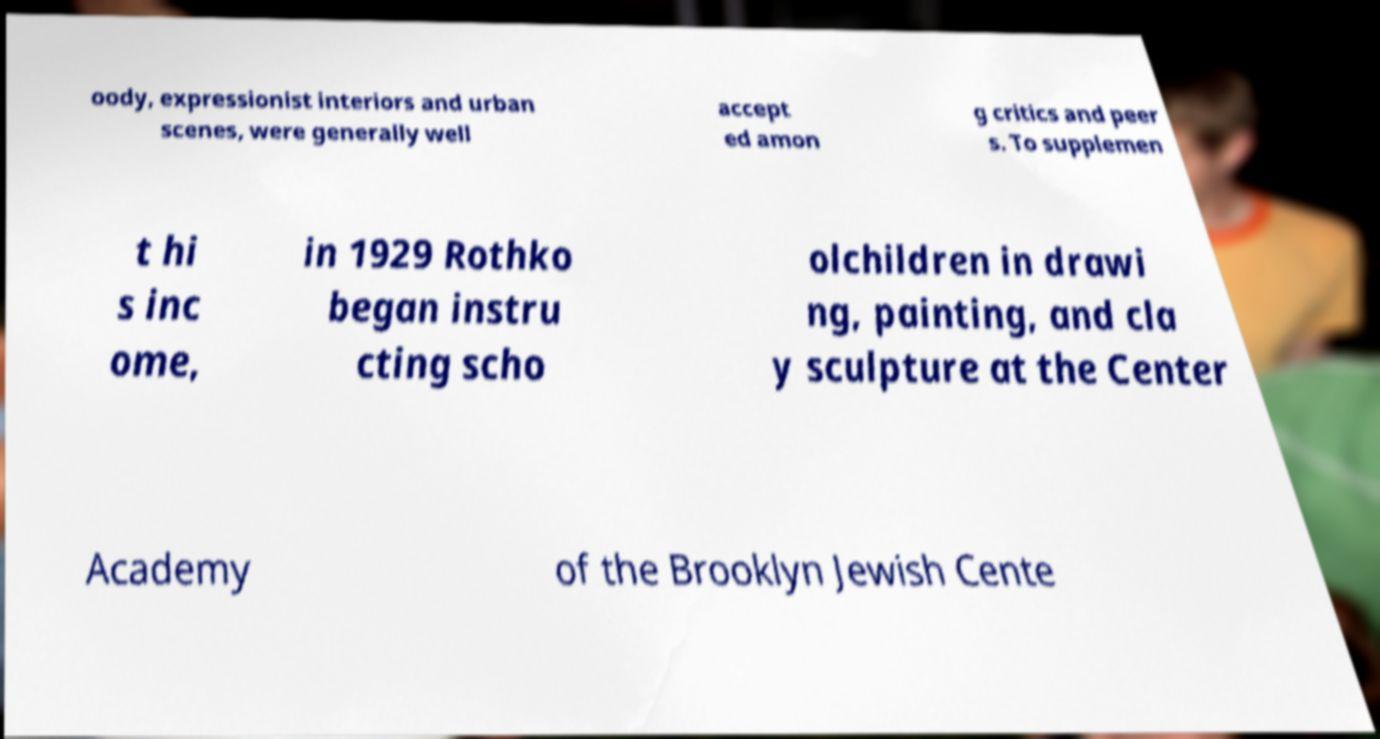Could you assist in decoding the text presented in this image and type it out clearly? oody, expressionist interiors and urban scenes, were generally well accept ed amon g critics and peer s. To supplemen t hi s inc ome, in 1929 Rothko began instru cting scho olchildren in drawi ng, painting, and cla y sculpture at the Center Academy of the Brooklyn Jewish Cente 